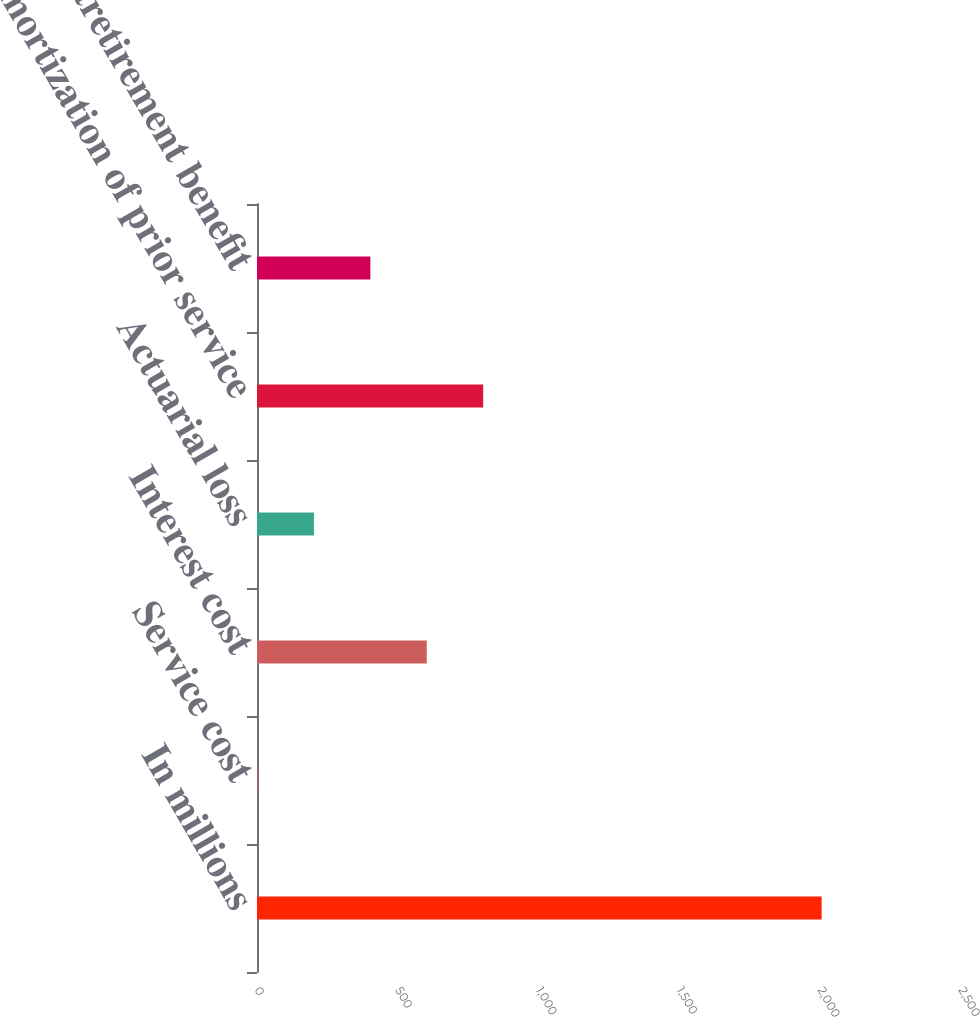<chart> <loc_0><loc_0><loc_500><loc_500><bar_chart><fcel>In millions<fcel>Service cost<fcel>Interest cost<fcel>Actuarial loss<fcel>Amortization of prior service<fcel>Net postretirement benefit<nl><fcel>2005<fcel>2<fcel>602.9<fcel>202.3<fcel>803.2<fcel>402.6<nl></chart> 